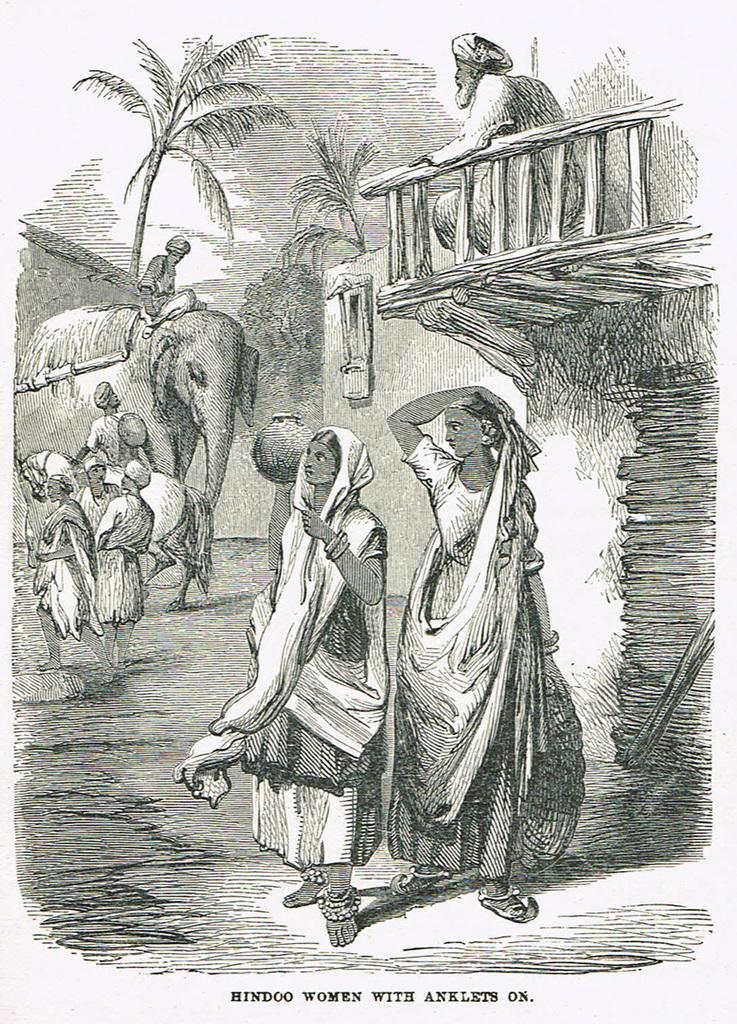In one or two sentences, can you explain what this image depicts? In this image we can see black and white picture of a drawing. In which we can see group of people standing. On the left side of the image we can see a person on an elephant. On the right side of the image we can see a person sitting, a building with a window and a railing. In the background, we can see a group of trees. At the bottom of the image we can see some text. 